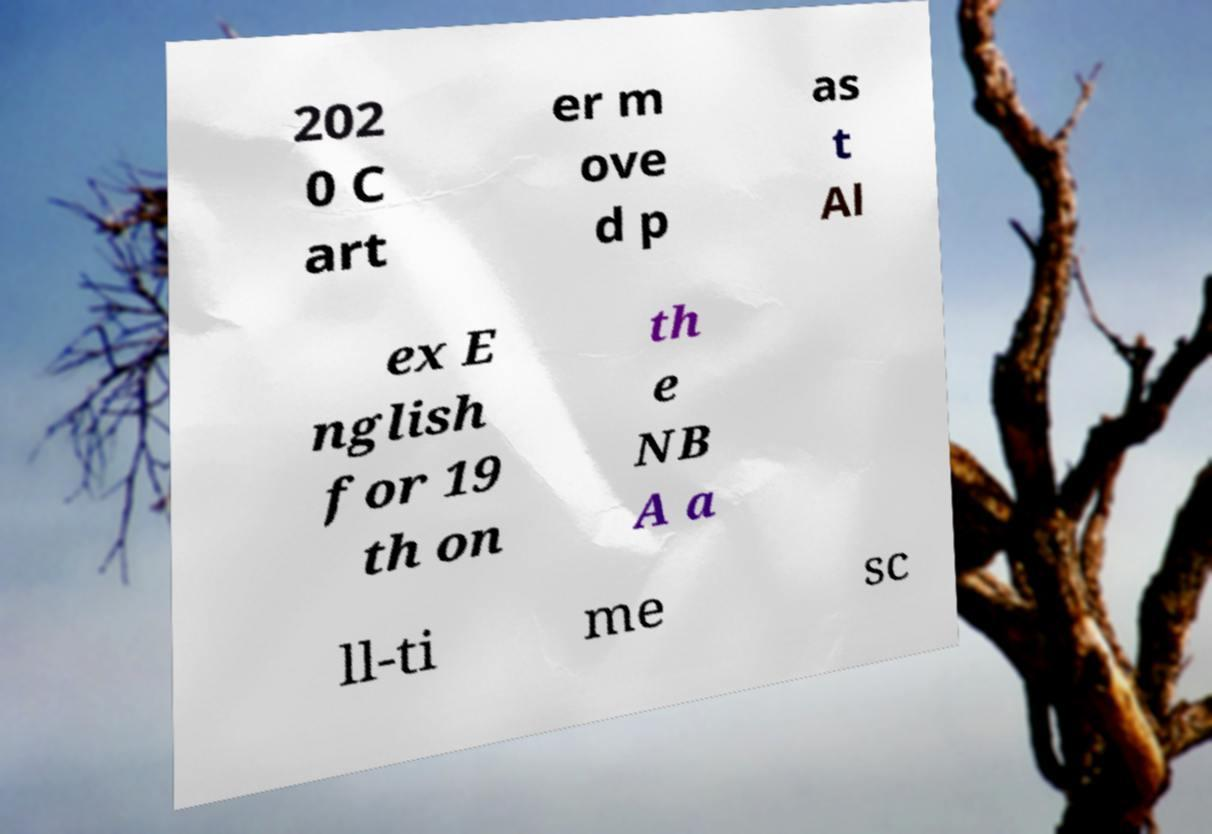Could you extract and type out the text from this image? 202 0 C art er m ove d p as t Al ex E nglish for 19 th on th e NB A a ll-ti me sc 